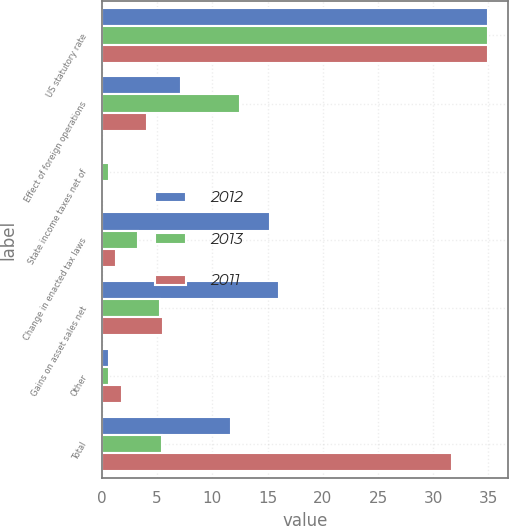Convert chart. <chart><loc_0><loc_0><loc_500><loc_500><stacked_bar_chart><ecel><fcel>US statutory rate<fcel>Effect of foreign operations<fcel>State income taxes net of<fcel>Change in enacted tax laws<fcel>Gains on asset sales net<fcel>Other<fcel>Total<nl><fcel>2012<fcel>35<fcel>7.2<fcel>0.1<fcel>15.2<fcel>16<fcel>0.6<fcel>11.7<nl><fcel>2013<fcel>35<fcel>12.5<fcel>0.6<fcel>3.3<fcel>5.3<fcel>0.6<fcel>5.4<nl><fcel>2011<fcel>35<fcel>4.1<fcel>0.1<fcel>1.3<fcel>5.5<fcel>1.8<fcel>31.7<nl></chart> 